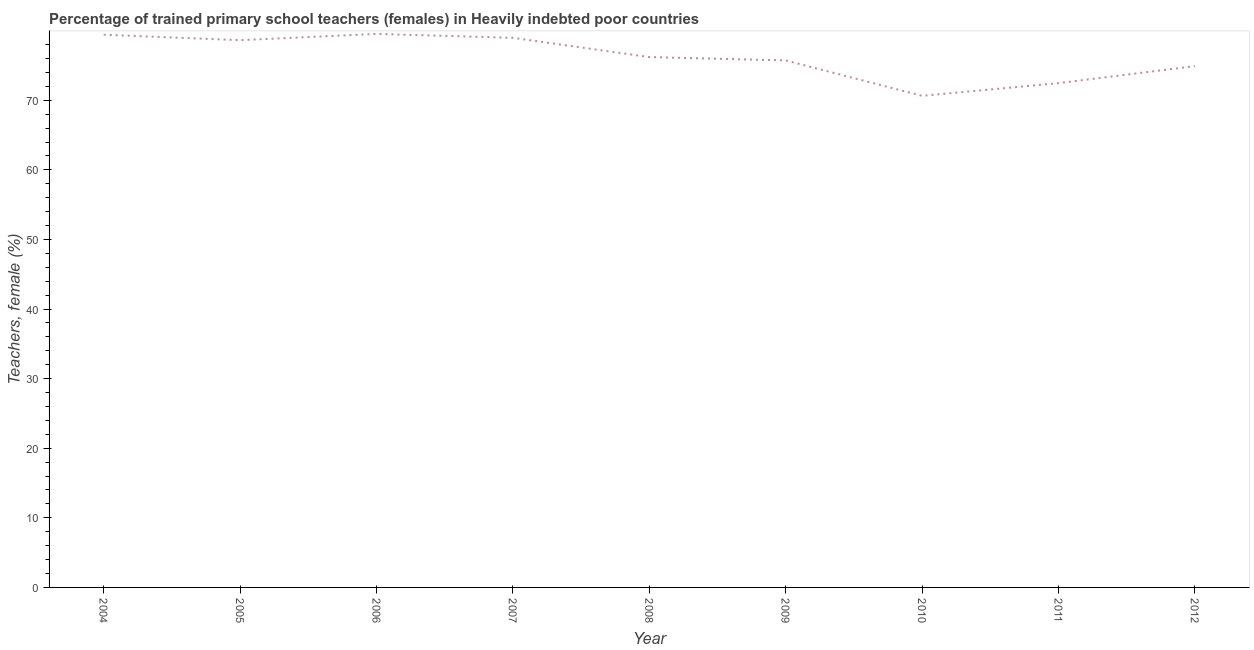What is the percentage of trained female teachers in 2009?
Your answer should be compact. 75.72. Across all years, what is the maximum percentage of trained female teachers?
Provide a succinct answer. 79.53. Across all years, what is the minimum percentage of trained female teachers?
Ensure brevity in your answer.  70.64. In which year was the percentage of trained female teachers maximum?
Your response must be concise. 2006. What is the sum of the percentage of trained female teachers?
Your answer should be very brief. 686.49. What is the difference between the percentage of trained female teachers in 2004 and 2012?
Offer a terse response. 4.51. What is the average percentage of trained female teachers per year?
Provide a succinct answer. 76.28. What is the median percentage of trained female teachers?
Your answer should be compact. 76.21. Do a majority of the years between 2010 and 2008 (inclusive) have percentage of trained female teachers greater than 6 %?
Offer a very short reply. No. What is the ratio of the percentage of trained female teachers in 2009 to that in 2012?
Make the answer very short. 1.01. Is the percentage of trained female teachers in 2008 less than that in 2009?
Offer a terse response. No. What is the difference between the highest and the second highest percentage of trained female teachers?
Provide a succinct answer. 0.12. Is the sum of the percentage of trained female teachers in 2007 and 2009 greater than the maximum percentage of trained female teachers across all years?
Your answer should be compact. Yes. What is the difference between the highest and the lowest percentage of trained female teachers?
Your response must be concise. 8.9. In how many years, is the percentage of trained female teachers greater than the average percentage of trained female teachers taken over all years?
Provide a succinct answer. 4. What is the difference between two consecutive major ticks on the Y-axis?
Ensure brevity in your answer.  10. What is the title of the graph?
Provide a succinct answer. Percentage of trained primary school teachers (females) in Heavily indebted poor countries. What is the label or title of the X-axis?
Offer a terse response. Year. What is the label or title of the Y-axis?
Provide a succinct answer. Teachers, female (%). What is the Teachers, female (%) in 2004?
Your response must be concise. 79.42. What is the Teachers, female (%) in 2005?
Your answer should be very brief. 78.63. What is the Teachers, female (%) of 2006?
Give a very brief answer. 79.53. What is the Teachers, female (%) of 2007?
Your response must be concise. 78.97. What is the Teachers, female (%) of 2008?
Give a very brief answer. 76.21. What is the Teachers, female (%) in 2009?
Provide a short and direct response. 75.72. What is the Teachers, female (%) of 2010?
Ensure brevity in your answer.  70.64. What is the Teachers, female (%) of 2011?
Ensure brevity in your answer.  72.46. What is the Teachers, female (%) of 2012?
Make the answer very short. 74.91. What is the difference between the Teachers, female (%) in 2004 and 2005?
Make the answer very short. 0.78. What is the difference between the Teachers, female (%) in 2004 and 2006?
Make the answer very short. -0.12. What is the difference between the Teachers, female (%) in 2004 and 2007?
Make the answer very short. 0.45. What is the difference between the Teachers, female (%) in 2004 and 2008?
Offer a very short reply. 3.21. What is the difference between the Teachers, female (%) in 2004 and 2009?
Offer a terse response. 3.69. What is the difference between the Teachers, female (%) in 2004 and 2010?
Your answer should be very brief. 8.78. What is the difference between the Teachers, female (%) in 2004 and 2011?
Keep it short and to the point. 6.95. What is the difference between the Teachers, female (%) in 2004 and 2012?
Your response must be concise. 4.51. What is the difference between the Teachers, female (%) in 2005 and 2006?
Provide a short and direct response. -0.9. What is the difference between the Teachers, female (%) in 2005 and 2007?
Give a very brief answer. -0.34. What is the difference between the Teachers, female (%) in 2005 and 2008?
Give a very brief answer. 2.43. What is the difference between the Teachers, female (%) in 2005 and 2009?
Offer a very short reply. 2.91. What is the difference between the Teachers, female (%) in 2005 and 2010?
Keep it short and to the point. 8. What is the difference between the Teachers, female (%) in 2005 and 2011?
Provide a short and direct response. 6.17. What is the difference between the Teachers, female (%) in 2005 and 2012?
Offer a very short reply. 3.73. What is the difference between the Teachers, female (%) in 2006 and 2007?
Offer a terse response. 0.56. What is the difference between the Teachers, female (%) in 2006 and 2008?
Your answer should be very brief. 3.33. What is the difference between the Teachers, female (%) in 2006 and 2009?
Your answer should be very brief. 3.81. What is the difference between the Teachers, female (%) in 2006 and 2010?
Keep it short and to the point. 8.9. What is the difference between the Teachers, female (%) in 2006 and 2011?
Make the answer very short. 7.07. What is the difference between the Teachers, female (%) in 2006 and 2012?
Your response must be concise. 4.63. What is the difference between the Teachers, female (%) in 2007 and 2008?
Provide a short and direct response. 2.76. What is the difference between the Teachers, female (%) in 2007 and 2009?
Give a very brief answer. 3.25. What is the difference between the Teachers, female (%) in 2007 and 2010?
Your answer should be compact. 8.34. What is the difference between the Teachers, female (%) in 2007 and 2011?
Ensure brevity in your answer.  6.51. What is the difference between the Teachers, female (%) in 2007 and 2012?
Offer a terse response. 4.06. What is the difference between the Teachers, female (%) in 2008 and 2009?
Your answer should be very brief. 0.48. What is the difference between the Teachers, female (%) in 2008 and 2010?
Your answer should be compact. 5.57. What is the difference between the Teachers, female (%) in 2008 and 2011?
Offer a terse response. 3.74. What is the difference between the Teachers, female (%) in 2008 and 2012?
Your answer should be compact. 1.3. What is the difference between the Teachers, female (%) in 2009 and 2010?
Ensure brevity in your answer.  5.09. What is the difference between the Teachers, female (%) in 2009 and 2011?
Keep it short and to the point. 3.26. What is the difference between the Teachers, female (%) in 2009 and 2012?
Your answer should be very brief. 0.82. What is the difference between the Teachers, female (%) in 2010 and 2011?
Your answer should be very brief. -1.83. What is the difference between the Teachers, female (%) in 2010 and 2012?
Provide a succinct answer. -4.27. What is the difference between the Teachers, female (%) in 2011 and 2012?
Offer a very short reply. -2.44. What is the ratio of the Teachers, female (%) in 2004 to that in 2006?
Keep it short and to the point. 1. What is the ratio of the Teachers, female (%) in 2004 to that in 2008?
Ensure brevity in your answer.  1.04. What is the ratio of the Teachers, female (%) in 2004 to that in 2009?
Your response must be concise. 1.05. What is the ratio of the Teachers, female (%) in 2004 to that in 2010?
Offer a very short reply. 1.12. What is the ratio of the Teachers, female (%) in 2004 to that in 2011?
Ensure brevity in your answer.  1.1. What is the ratio of the Teachers, female (%) in 2004 to that in 2012?
Provide a succinct answer. 1.06. What is the ratio of the Teachers, female (%) in 2005 to that in 2007?
Provide a short and direct response. 1. What is the ratio of the Teachers, female (%) in 2005 to that in 2008?
Make the answer very short. 1.03. What is the ratio of the Teachers, female (%) in 2005 to that in 2009?
Your answer should be compact. 1.04. What is the ratio of the Teachers, female (%) in 2005 to that in 2010?
Provide a succinct answer. 1.11. What is the ratio of the Teachers, female (%) in 2005 to that in 2011?
Provide a succinct answer. 1.08. What is the ratio of the Teachers, female (%) in 2006 to that in 2007?
Provide a short and direct response. 1.01. What is the ratio of the Teachers, female (%) in 2006 to that in 2008?
Keep it short and to the point. 1.04. What is the ratio of the Teachers, female (%) in 2006 to that in 2009?
Give a very brief answer. 1.05. What is the ratio of the Teachers, female (%) in 2006 to that in 2010?
Make the answer very short. 1.13. What is the ratio of the Teachers, female (%) in 2006 to that in 2011?
Offer a terse response. 1.1. What is the ratio of the Teachers, female (%) in 2006 to that in 2012?
Ensure brevity in your answer.  1.06. What is the ratio of the Teachers, female (%) in 2007 to that in 2008?
Provide a succinct answer. 1.04. What is the ratio of the Teachers, female (%) in 2007 to that in 2009?
Make the answer very short. 1.04. What is the ratio of the Teachers, female (%) in 2007 to that in 2010?
Give a very brief answer. 1.12. What is the ratio of the Teachers, female (%) in 2007 to that in 2011?
Your response must be concise. 1.09. What is the ratio of the Teachers, female (%) in 2007 to that in 2012?
Offer a very short reply. 1.05. What is the ratio of the Teachers, female (%) in 2008 to that in 2009?
Make the answer very short. 1.01. What is the ratio of the Teachers, female (%) in 2008 to that in 2010?
Ensure brevity in your answer.  1.08. What is the ratio of the Teachers, female (%) in 2008 to that in 2011?
Your answer should be very brief. 1.05. What is the ratio of the Teachers, female (%) in 2008 to that in 2012?
Offer a very short reply. 1.02. What is the ratio of the Teachers, female (%) in 2009 to that in 2010?
Keep it short and to the point. 1.07. What is the ratio of the Teachers, female (%) in 2009 to that in 2011?
Keep it short and to the point. 1.04. What is the ratio of the Teachers, female (%) in 2009 to that in 2012?
Give a very brief answer. 1.01. What is the ratio of the Teachers, female (%) in 2010 to that in 2011?
Provide a short and direct response. 0.97. What is the ratio of the Teachers, female (%) in 2010 to that in 2012?
Ensure brevity in your answer.  0.94. 